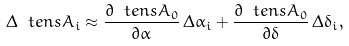Convert formula to latex. <formula><loc_0><loc_0><loc_500><loc_500>\Delta \ t e n s { A } _ { i } \approx \frac { \partial \ t e n s { A } _ { 0 } } { \partial \alpha } \, \Delta \alpha _ { i } + \frac { \partial \ t e n s { A } _ { 0 } } { \partial \delta } \, \Delta \delta _ { i } ,</formula> 